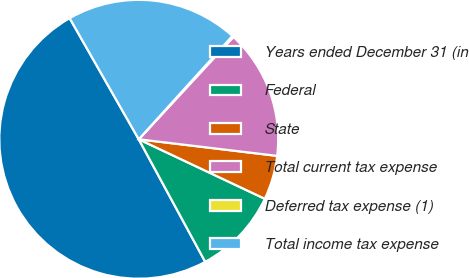Convert chart. <chart><loc_0><loc_0><loc_500><loc_500><pie_chart><fcel>Years ended December 31 (in<fcel>Federal<fcel>State<fcel>Total current tax expense<fcel>Deferred tax expense (1)<fcel>Total income tax expense<nl><fcel>49.67%<fcel>10.07%<fcel>5.12%<fcel>15.02%<fcel>0.17%<fcel>19.97%<nl></chart> 